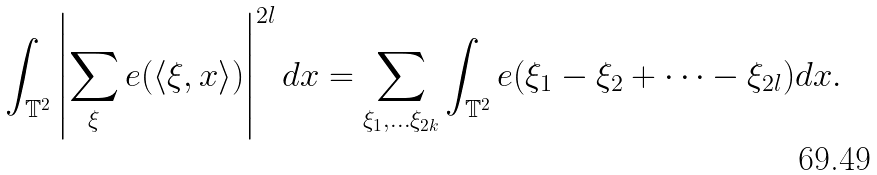<formula> <loc_0><loc_0><loc_500><loc_500>\int _ { \mathbb { T } ^ { 2 } } \left | \sum _ { \xi } e ( \langle \xi , x \rangle ) \right | ^ { 2 l } d x = \sum _ { \xi _ { 1 } , \dots \xi _ { 2 k } } \int _ { \mathbb { T } ^ { 2 } } e ( \xi _ { 1 } - \xi _ { 2 } + \dots - \xi _ { 2 l } ) d x .</formula> 